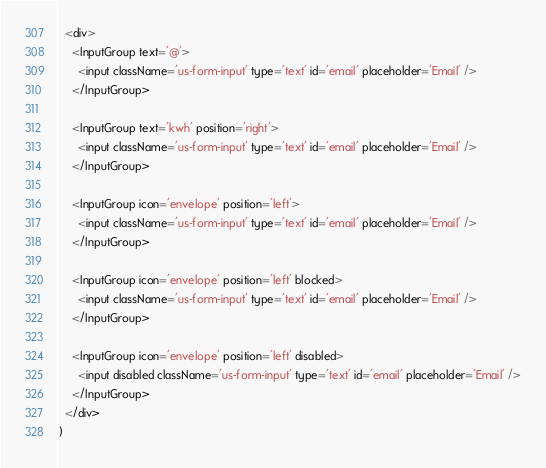<code> <loc_0><loc_0><loc_500><loc_500><_JavaScript_>  <div>
    <InputGroup text='@'>
      <input className='us-form-input' type='text' id='email' placeholder='Email' />
    </InputGroup>

    <InputGroup text='kwh' position='right'>
      <input className='us-form-input' type='text' id='email' placeholder='Email' />
    </InputGroup>

    <InputGroup icon='envelope' position='left'>
      <input className='us-form-input' type='text' id='email' placeholder='Email' />
    </InputGroup>

    <InputGroup icon='envelope' position='left' blocked>
      <input className='us-form-input' type='text' id='email' placeholder='Email' />
    </InputGroup>

    <InputGroup icon='envelope' position='left' disabled>
      <input disabled className='us-form-input' type='text' id='email' placeholder='Email' />
    </InputGroup>
  </div>
)
</code> 